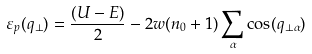<formula> <loc_0><loc_0><loc_500><loc_500>\varepsilon _ { p } ( { q } _ { \perp } ) = \frac { ( U - E ) } { 2 } - 2 w ( n _ { 0 } + 1 ) \sum _ { \alpha } \cos ( q _ { \perp \alpha } )</formula> 